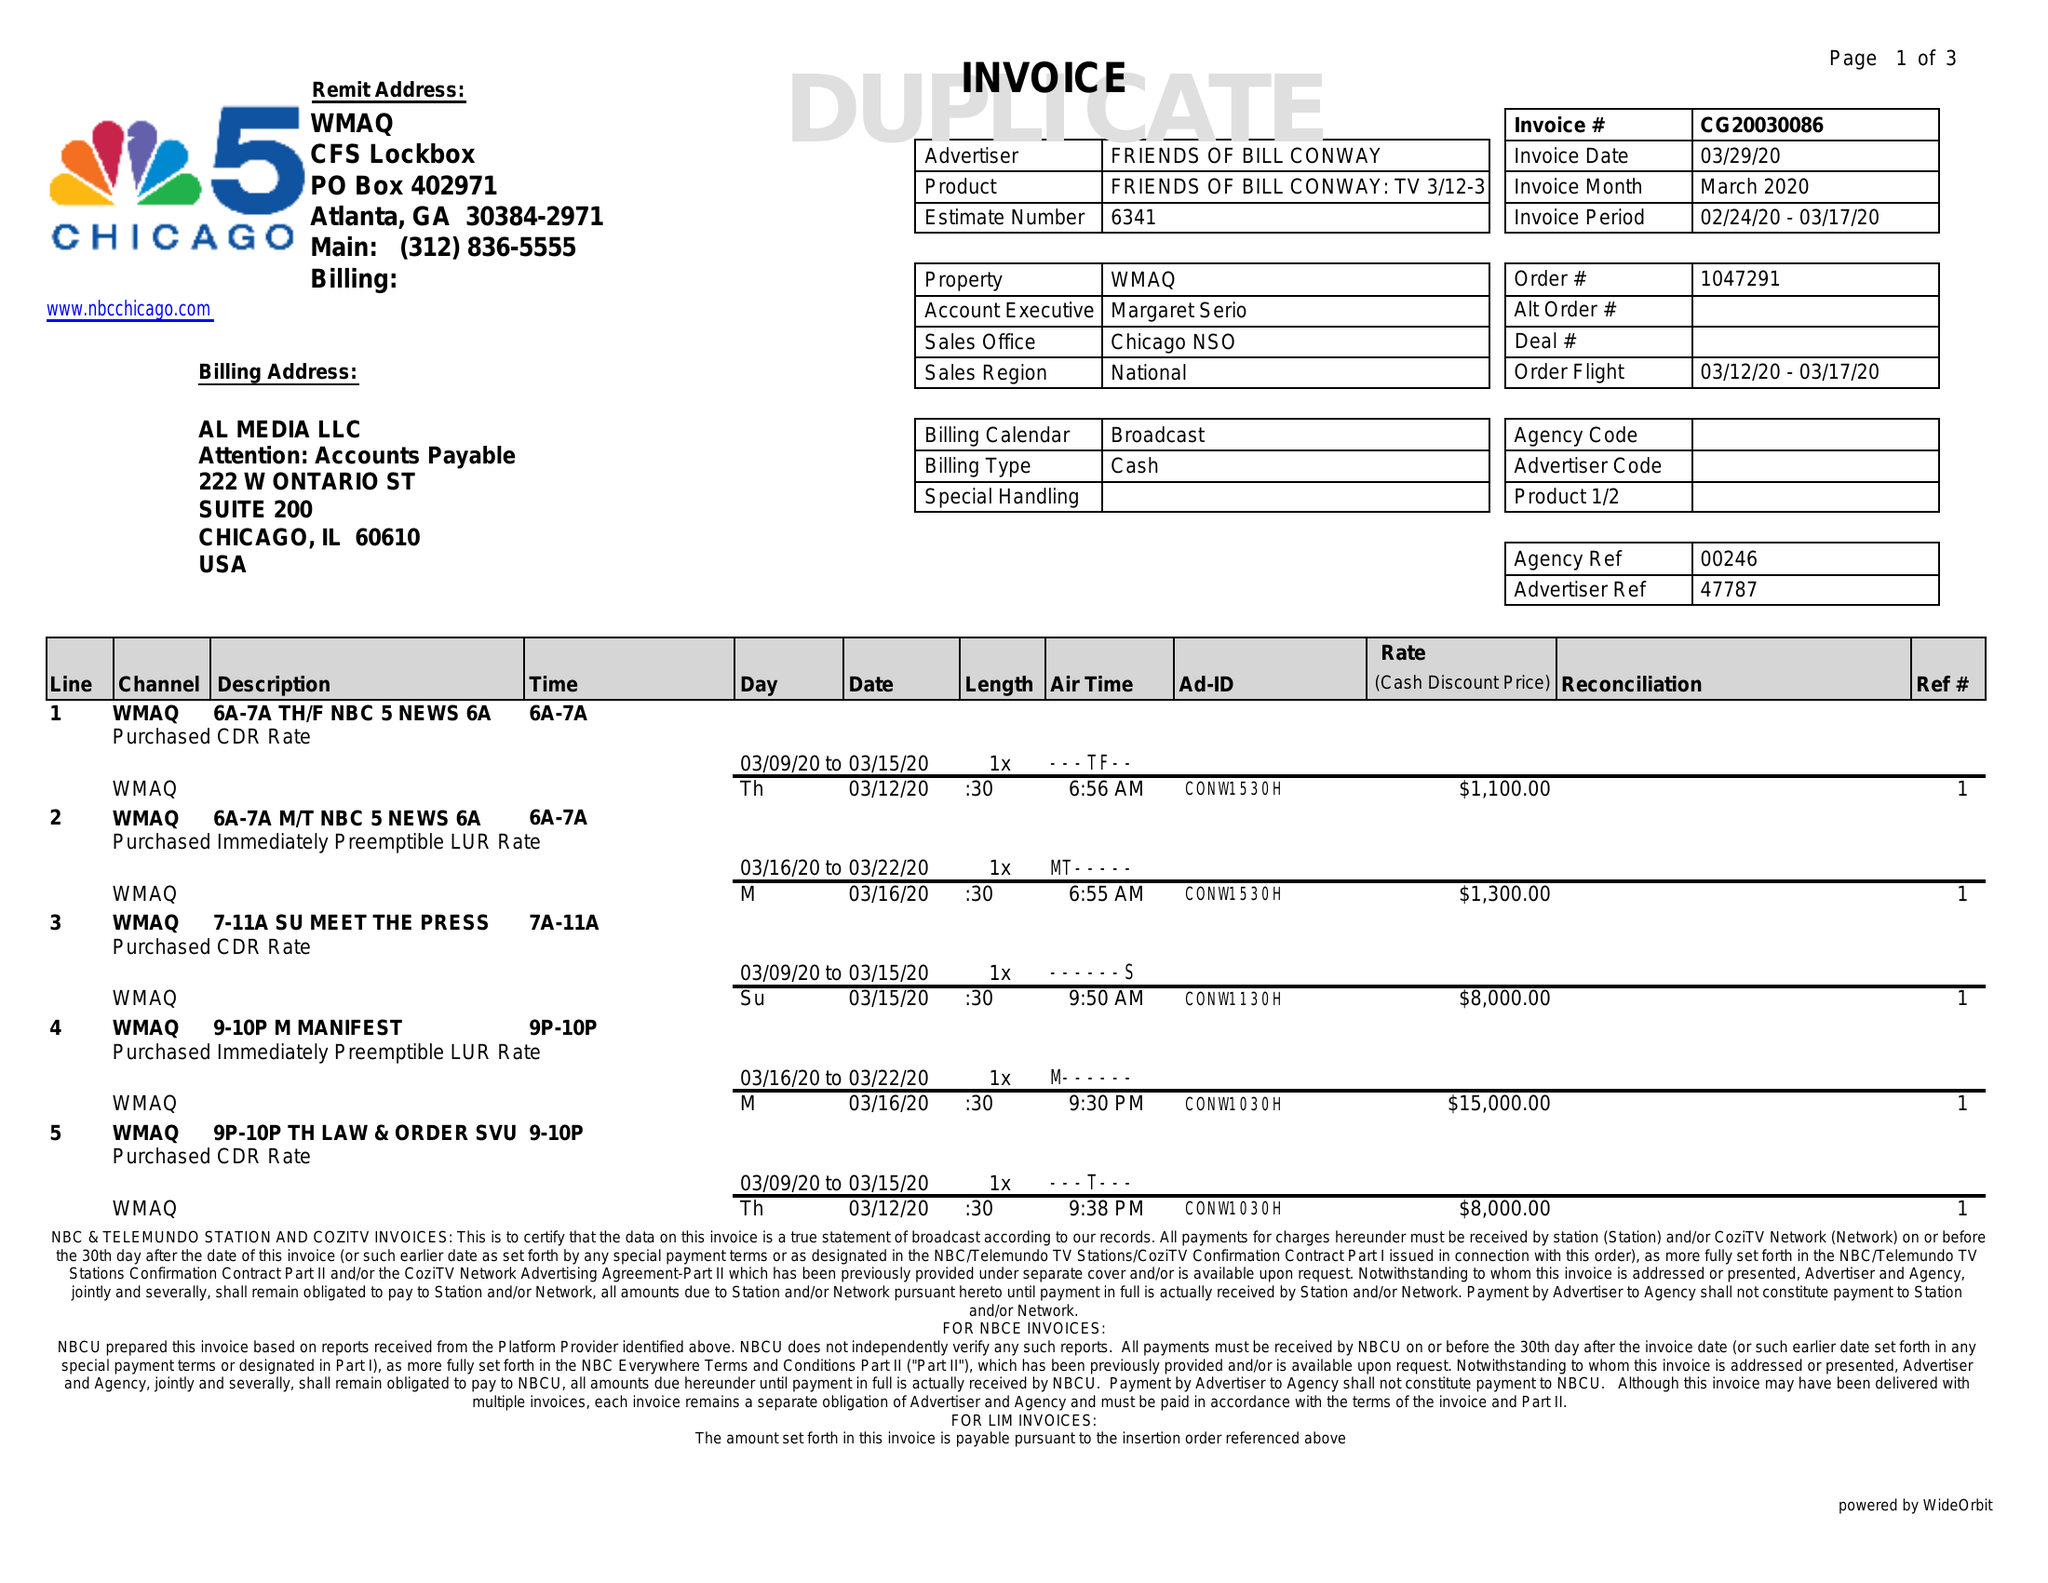What is the value for the gross_amount?
Answer the question using a single word or phrase. 41200.00 